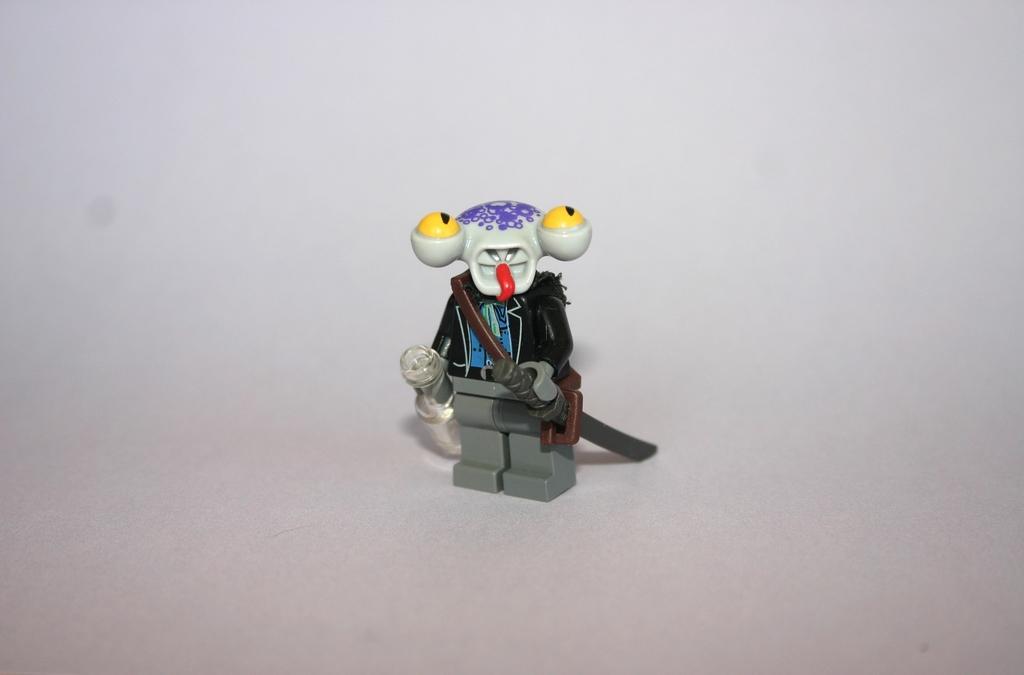Can you describe this image briefly? In this picture I can see a toy of a person. 